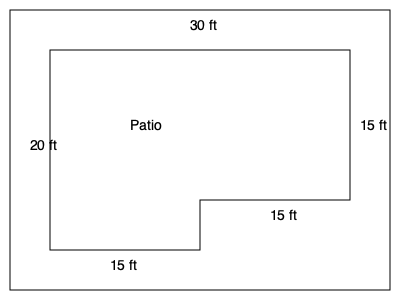A homeowner wants to install a decorative border around their irregularly shaped patio. Calculate the perimeter of the patio shown in the diagram to determine how many linear feet of border material is needed. Round your answer to the nearest foot. To calculate the perimeter of the irregularly shaped patio, we need to add up the lengths of all sides:

1. Top side: $30$ ft
2. Right side: $15$ ft
3. Bottom-right side: $15$ ft
4. Bottom-left side: $15$ ft
5. Left side: $20$ ft

Adding these lengths:

$$\text{Perimeter} = 30 + 15 + 15 + 15 + 20 = 95 \text{ ft}$$

Since the question asks to round to the nearest foot, and 95 is already a whole number, no rounding is necessary.
Answer: 95 ft 